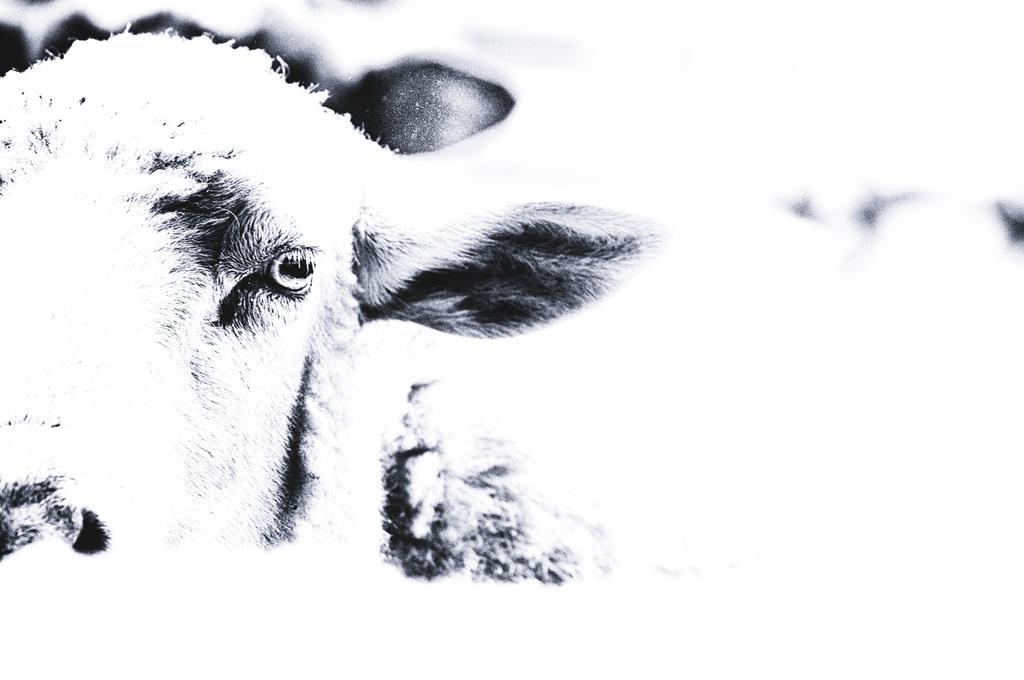Can you describe this image briefly? There is an animal in the left corner. 